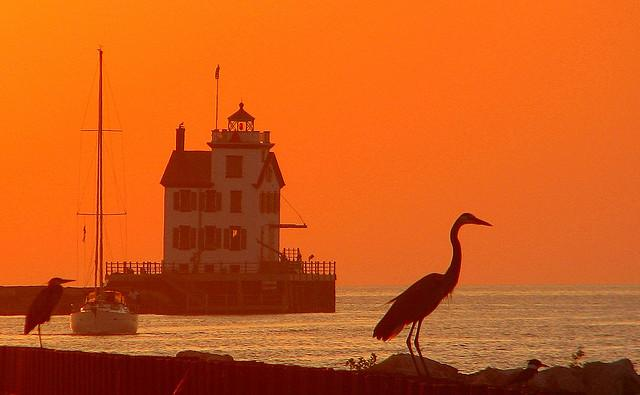What are the birds in front of? Please explain your reasoning. house. The birds are in front of a large house that sits next to the water. 